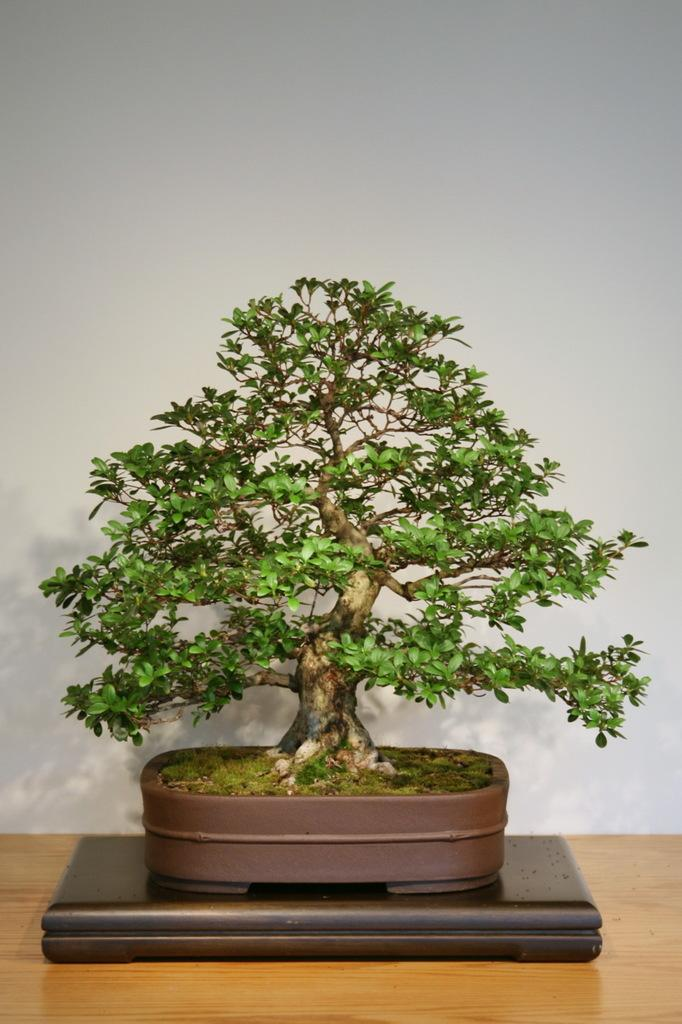What type of plant is in the image? There is a bonsai plant in the image. What is the bonsai plant placed on? The bonsai plant is on a brown surface. What can be seen in the background of the image? There is a white wall in the background of the image. What type of lock is used to secure the ship in the image? There is no ship or lock present in the image; it features a bonsai plant on a brown surface with a white wall in the background. 